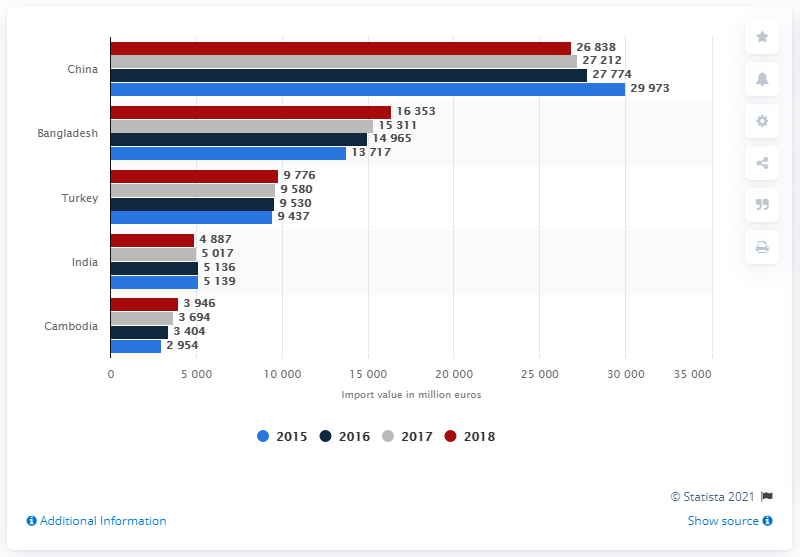Indicate a few pertinent items in this graphic. The European Union imported clothing primarily from China in 2018. In the year 2018, the total amount of cloth produced by China and India was 31,725 units. In 2018, the European Union imported a significant amount of clothing from China, totaling 26,838. It is widely believed that China is the country that produces the largest quantity of clothing products. 